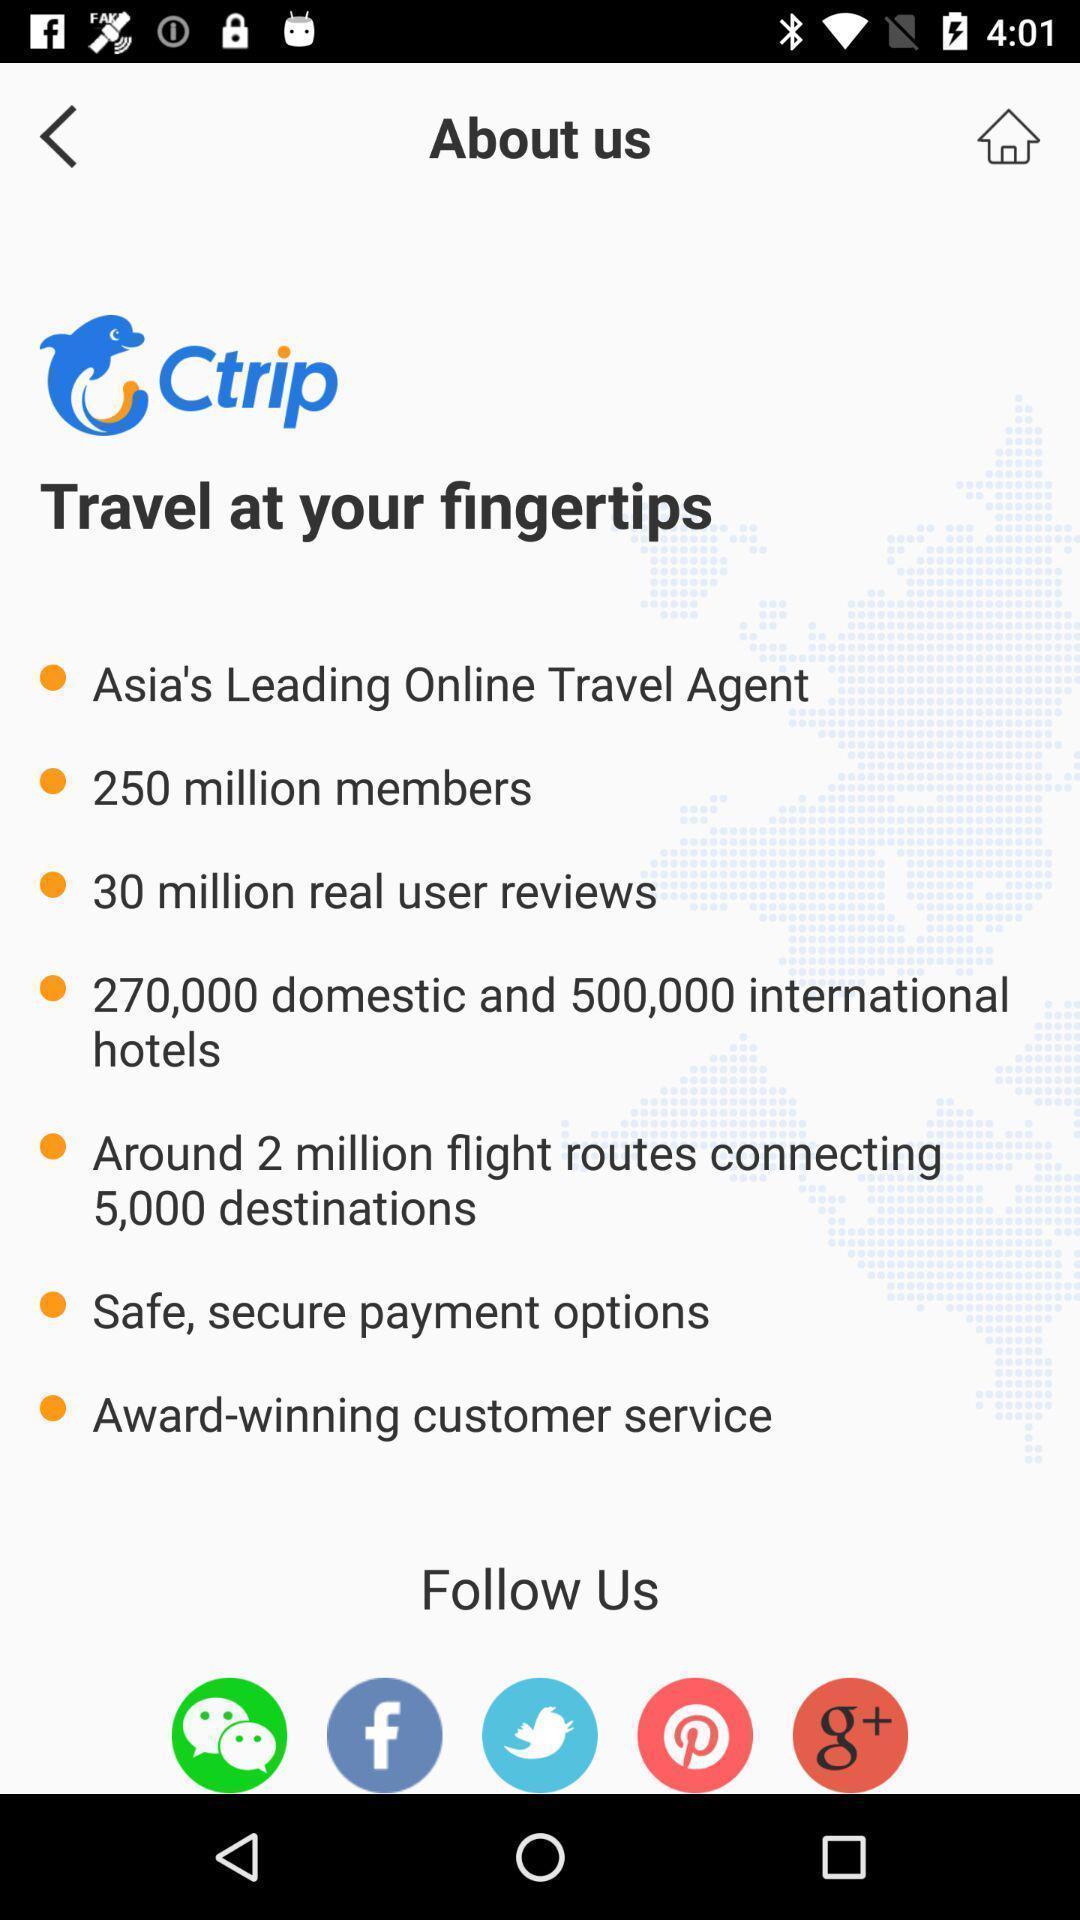Tell me about the visual elements in this screen capture. Screen shows about us page in a travel app. 